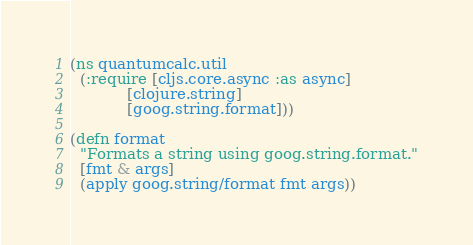<code> <loc_0><loc_0><loc_500><loc_500><_Clojure_>(ns quantumcalc.util
  (:require [cljs.core.async :as async]
            [clojure.string]
            [goog.string.format]))

(defn format
  "Formats a string using goog.string.format."
  [fmt & args]
  (apply goog.string/format fmt args))
</code> 